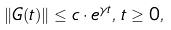Convert formula to latex. <formula><loc_0><loc_0><loc_500><loc_500>\| G ( t ) \| \leq c \cdot e ^ { \gamma t } , \, t \geq 0 ,</formula> 